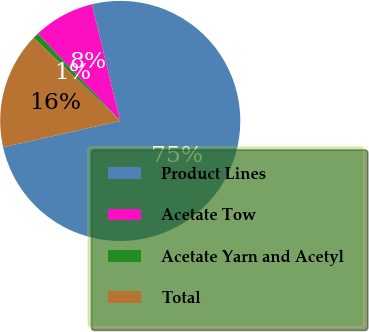Convert chart to OTSL. <chart><loc_0><loc_0><loc_500><loc_500><pie_chart><fcel>Product Lines<fcel>Acetate Tow<fcel>Acetate Yarn and Acetyl<fcel>Total<nl><fcel>75.29%<fcel>8.24%<fcel>0.79%<fcel>15.69%<nl></chart> 